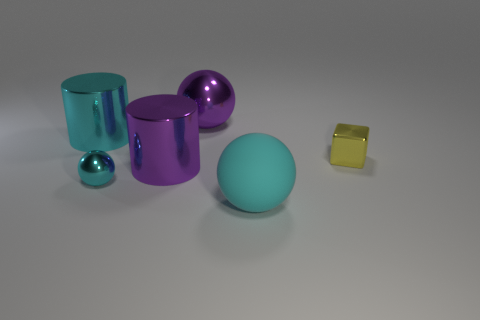What size is the purple cylinder that is the same material as the cube? The purple cylinder in the image is large when compared to the other objects present. Its size is most closely comparable to the teal cylinder lying on its side yet slightly shorter than the teal, suggesting a noticeable, but not overwhelming, presence among the set of objects. 